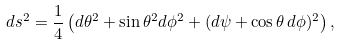Convert formula to latex. <formula><loc_0><loc_0><loc_500><loc_500>d s ^ { 2 } = \frac { 1 } { 4 } \left ( d \theta ^ { 2 } + \sin \theta ^ { 2 } d \phi ^ { 2 } + ( d \psi + \cos \theta \, d \phi ) ^ { 2 } \right ) ,</formula> 